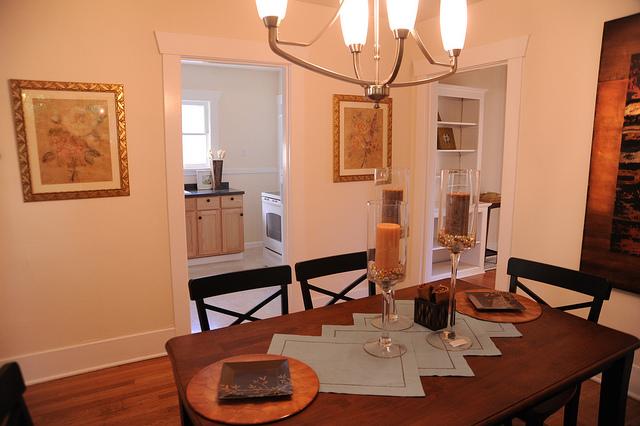Are more chairs unoccupied than occupied in this photo?
Concise answer only. Yes. What is on the ceiling?
Give a very brief answer. Light. What color are the chairs?
Keep it brief. Black. What color is the table?
Keep it brief. Brown. Is this a nice house?
Short answer required. Yes. What room is this?
Short answer required. Dining room. Is anyone eating at this table?
Answer briefly. No. What is providing light for the table?
Be succinct. Chandelier. Is the table set for dinner?
Keep it brief. Yes. 